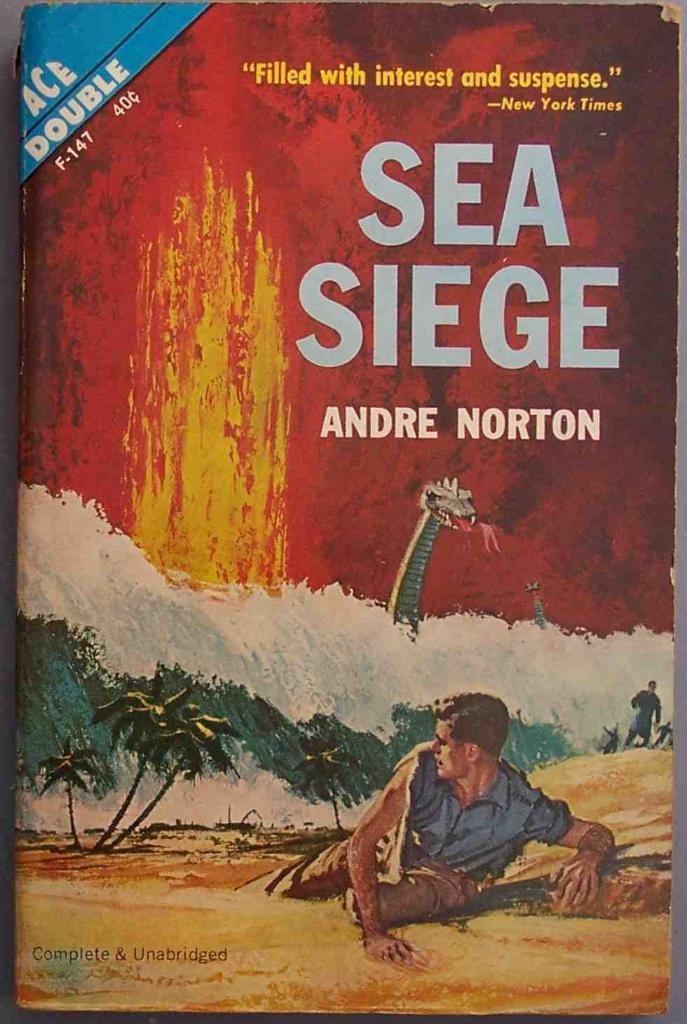<image>
Describe the image concisely. a book that is called Sea Siege with a painting of a person 